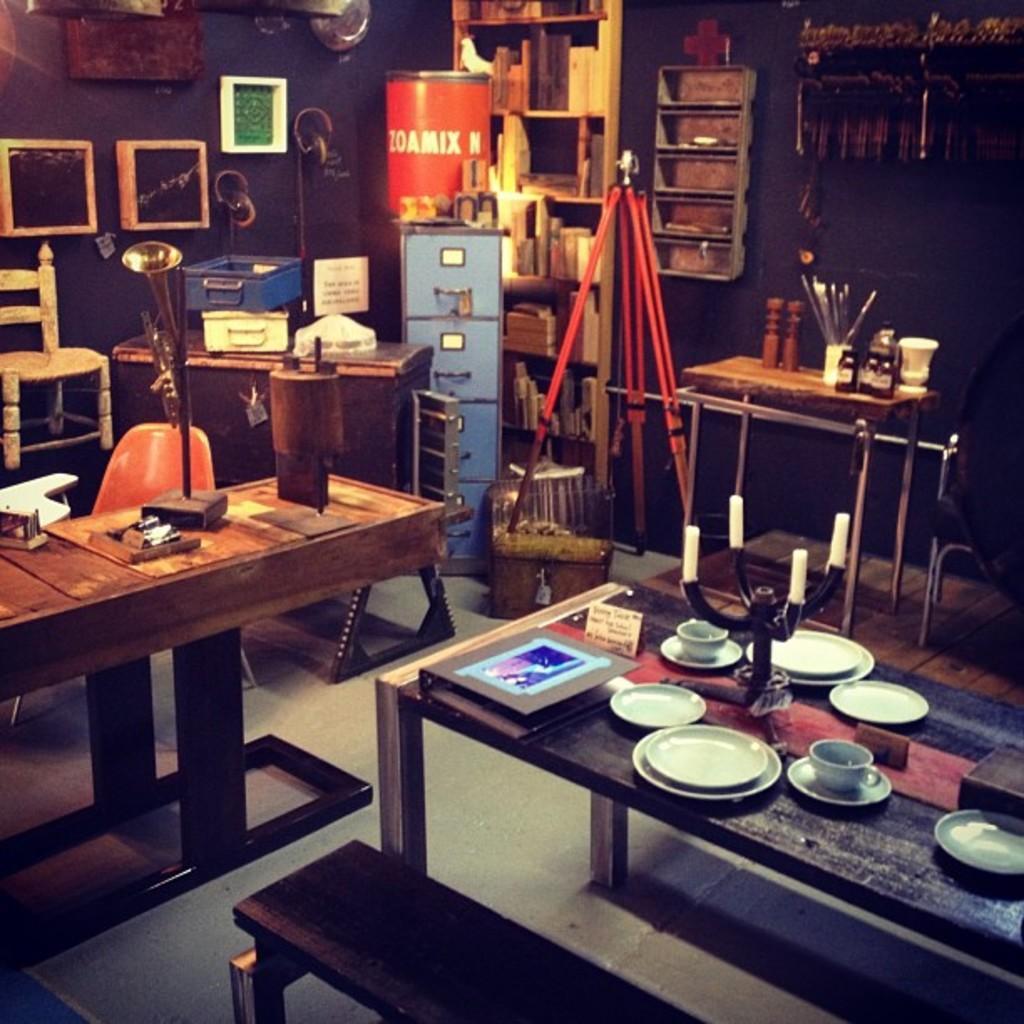Describe this image in one or two sentences. In this picture we can see few plates, cups, frame and other things on the tables, in the background we can see a box, chairs, cupboards, barrel and few frames on the wall. 